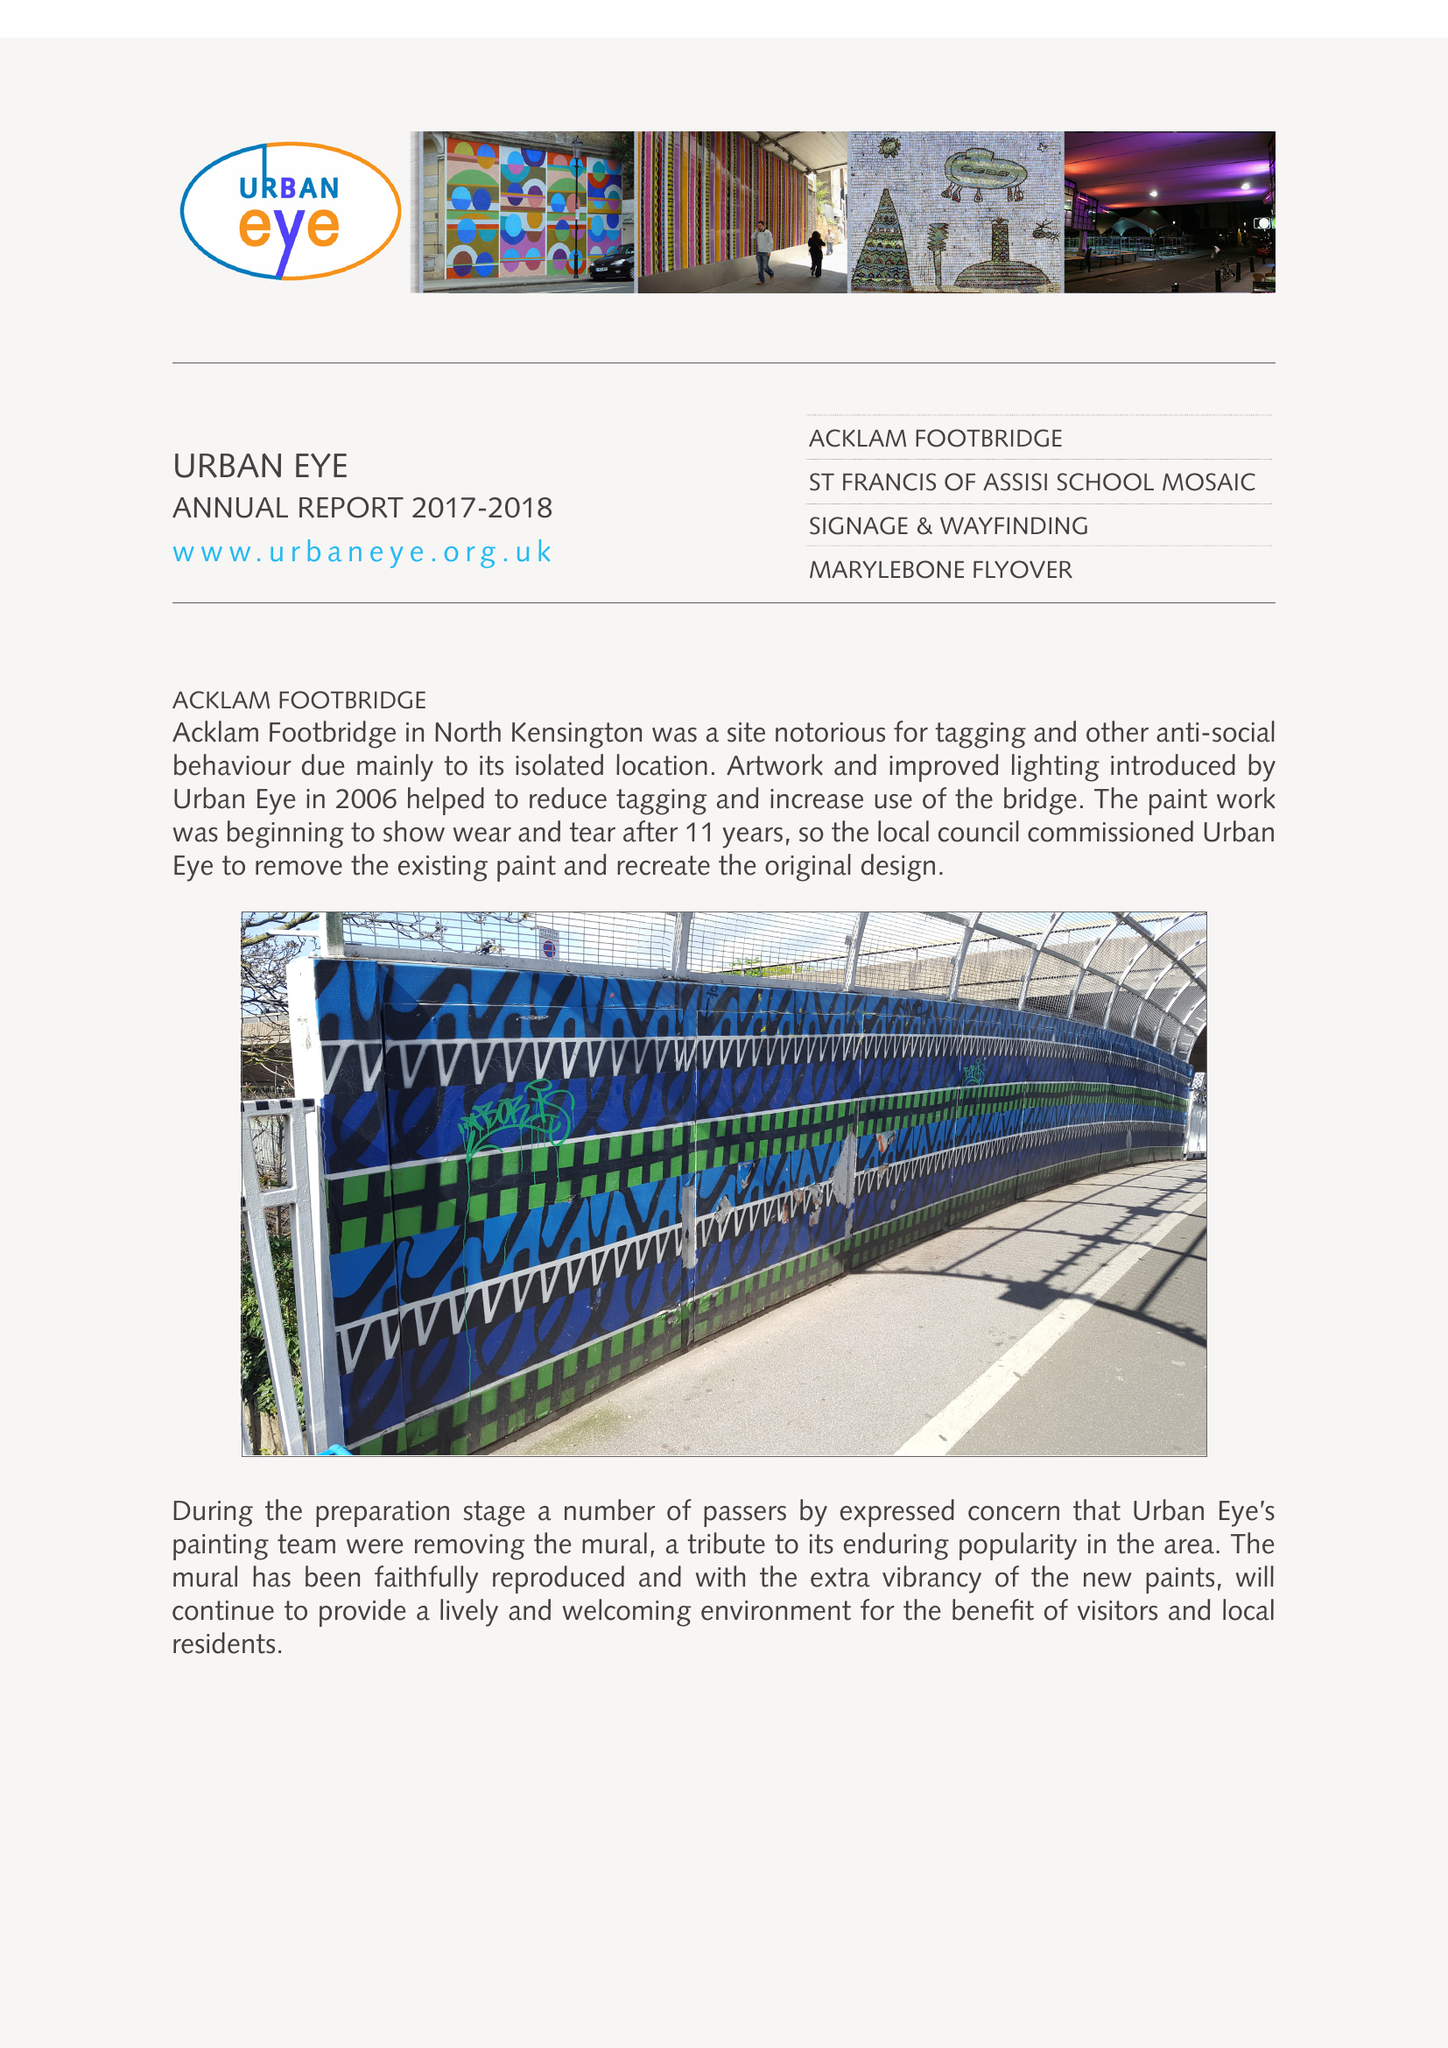What is the value for the charity_name?
Answer the question using a single word or phrase. Urban Eye 